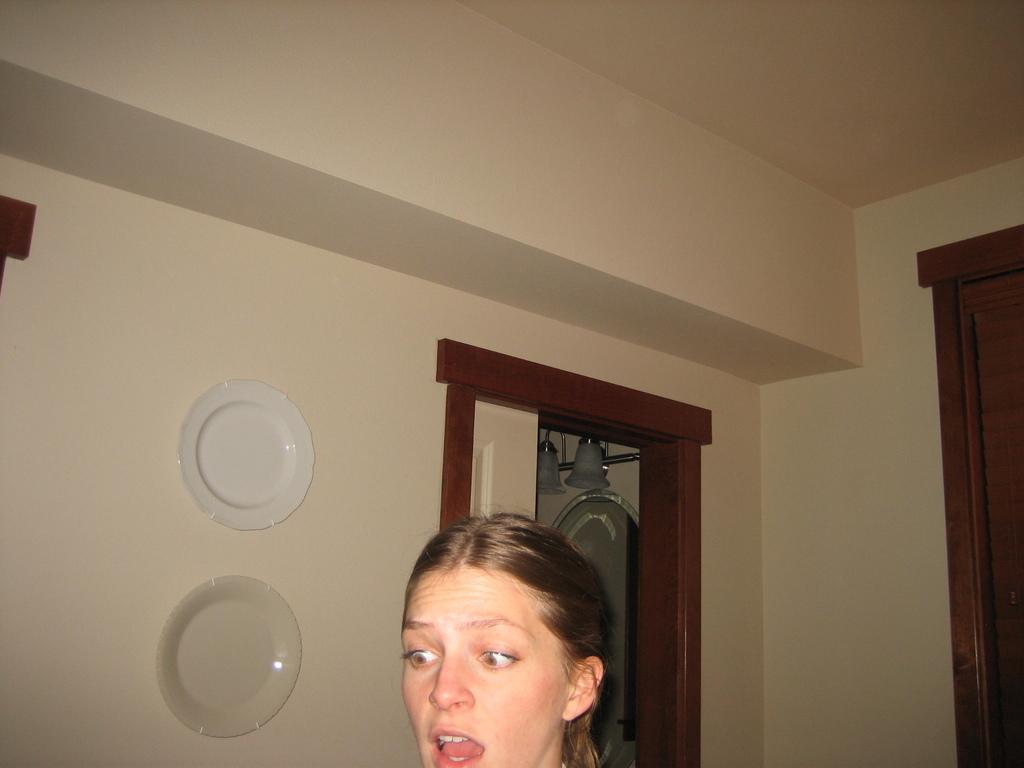Please provide a concise description of this image. In this image we can see face of a woman. Behind wall and doors are present. Plates are attached to the wall. 